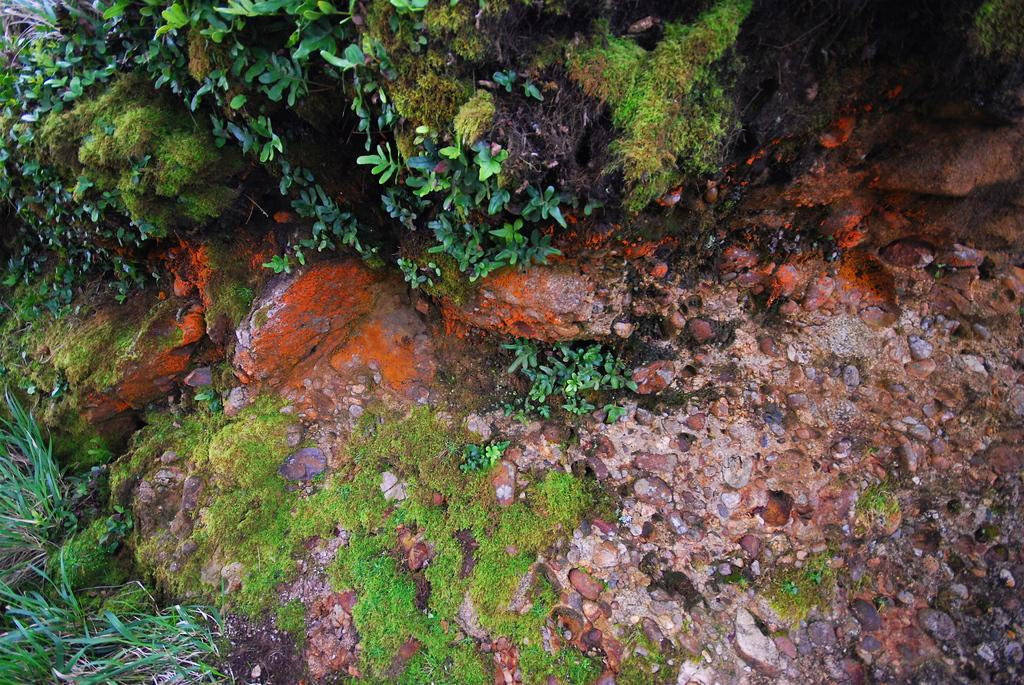What type of vegetation can be seen in the image? There are plants and grass in the image. What other elements can be found in the image? There are stones and rocks in the image. Where is the kitty located in the image? There is no kitty present in the image. What is the wishing stone in the image? There is no mention of a wishing stone in the image; it only contains plants, grass, stones, and rocks. 